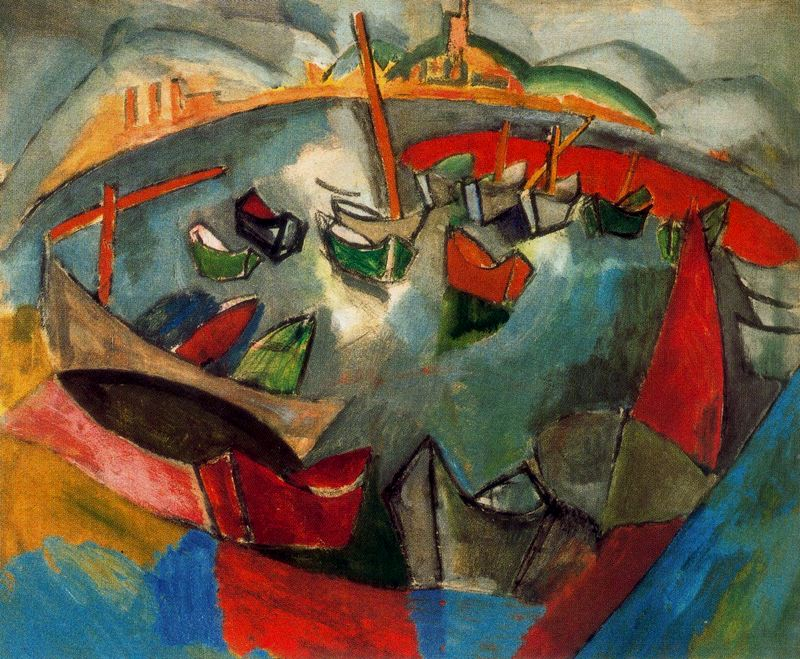What is this photo about'?
 The image is an abstract representation of a harbor scene, painted in a post-impressionist style. The scene is filled with boats, depicted in a distorted and exaggerated manner, their forms blending together in a dynamic dance of color and shape. The background is a vibrant mix of blue and green, with hints of orange and red peeking through, adding depth and complexity to the scene. The overall mood of the painting is one of chaos and dynamism, capturing the constant movement and energy of a bustling harbor. 